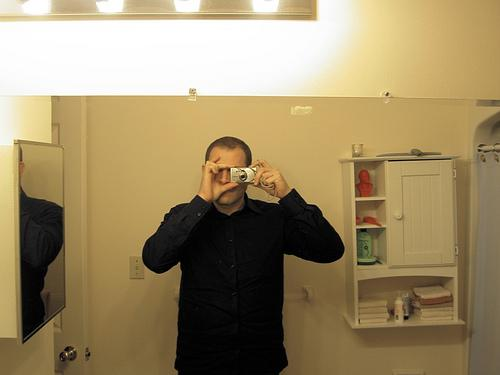Question: where was this photo taken?
Choices:
A. Bedroom.
B. In a bathroom.
C. Professional Studio.
D. Clubhouse.
Answer with the letter. Answer: B Question: who is present?
Choices:
A. Friends.
B. Woman.
C. A man.
D. Girl.
Answer with the letter. Answer: C Question: how is the photo?
Choices:
A. Blurry.
B. Clear.
C. Black and white.
D. Yellow.
Answer with the letter. Answer: B Question: why is he standing?
Choices:
A. Stretching.
B. Walking.
C. To take the photo.
D. To greet.
Answer with the letter. Answer: C Question: what color is he?
Choices:
A. Brown.
B. Black.
C. White.
D. Yellow.
Answer with the letter. Answer: C 